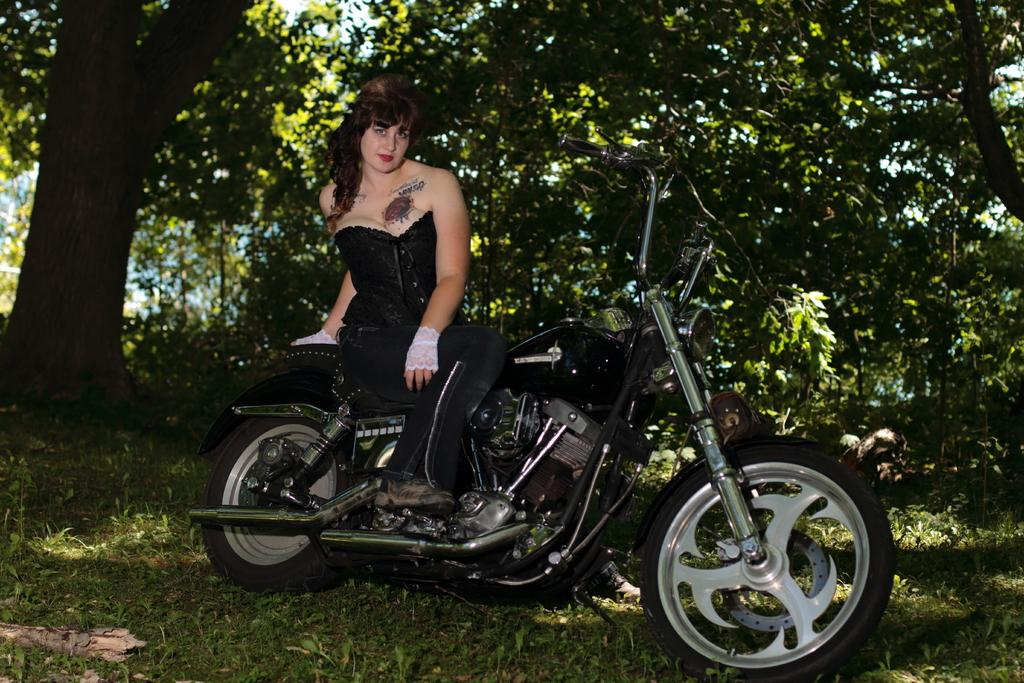What is the woman doing in the image? The woman is sitting on a bike in the image. What can be seen in the background of the image? There are trees with green leaves in the background of the image. What type of vegetation is visible at the bottom of the image? There is grass visible at the bottom of the image. Can you see any roses in the garden in the image? There is no garden or roses present in the image. 